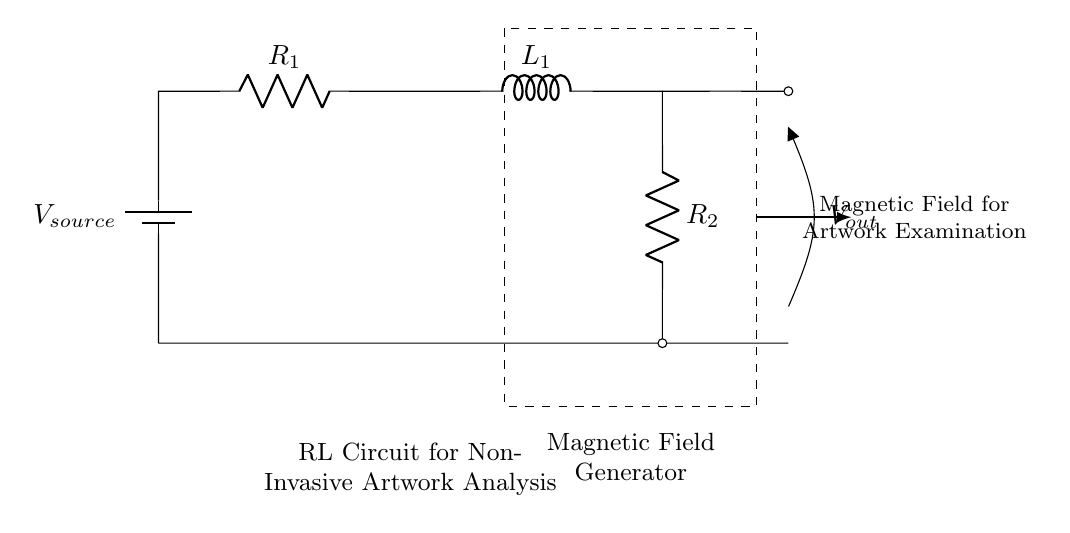What is the value of the voltage source? The circuit diagram shows a voltage source labeled as V_source, indicating it provides the necessary voltage for the circuit to operate, but it does not specify a numerical value. Therefore, the exact value is uncertain based on the diagram alone.
Answer: V_source What components are included in this circuit? The circuit contains a voltage source, two resistors (R1 and R2), and one inductor (L1). These components are explicitly labeled in the circuit diagram, allowing for easy identification.
Answer: Voltage source, R1, L1, R2 What is the purpose of the inductor in this circuit? The inductor L1 stores energy in a magnetic field when current flows through it. In combination with the resistors, it helps create a specific magnetic field essential for the non-invasive examination of artwork in this application.
Answer: Energy storage, magnetic field generation How many resistors are present in the circuit? The circuit contains two resistors (R1 and R2). Counting the components in the diagram confirms that both are visibly present and labeled.
Answer: 2 What does the dashed rectangle represent? The dashed rectangle encloses the components marked as a "Magnetic Field Generator," indicating that the enclosed components operate together to generate a magnetic field for examination purposes.
Answer: Magnetic Field Generator What is the role of the output voltage labeled as V_out? The labeled output voltage V_out represents the voltage across the output terminals of the circuit, which typically delivers the potential used in generating the magnetic field necessary for artwork analysis.
Answer: Output voltage What type of circuit is represented by the combination of resistors and an inductor? The circuit is an "RL Circuit," which is characterized by the combination of resistors (R) and inductors (L). This type of circuit is used to analyze transient responses and create magnetic fields.
Answer: RL Circuit 